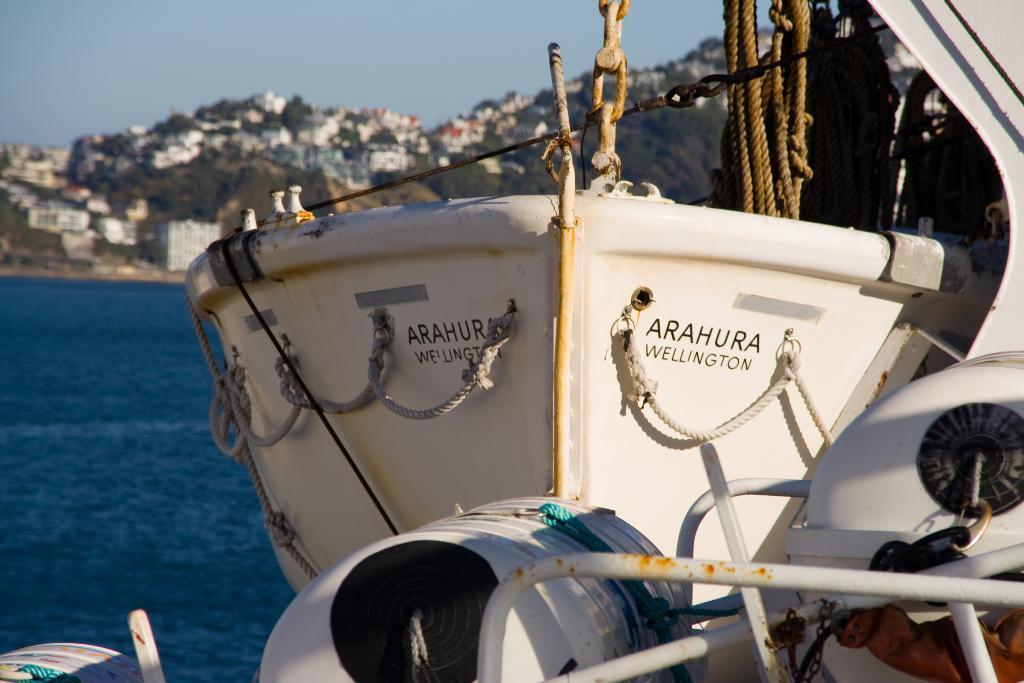In one or two sentences, can you explain what this image depicts? In the image we can see a boat, this is a rope and a chain. There is a water, there are buildings, trees and a sky. 